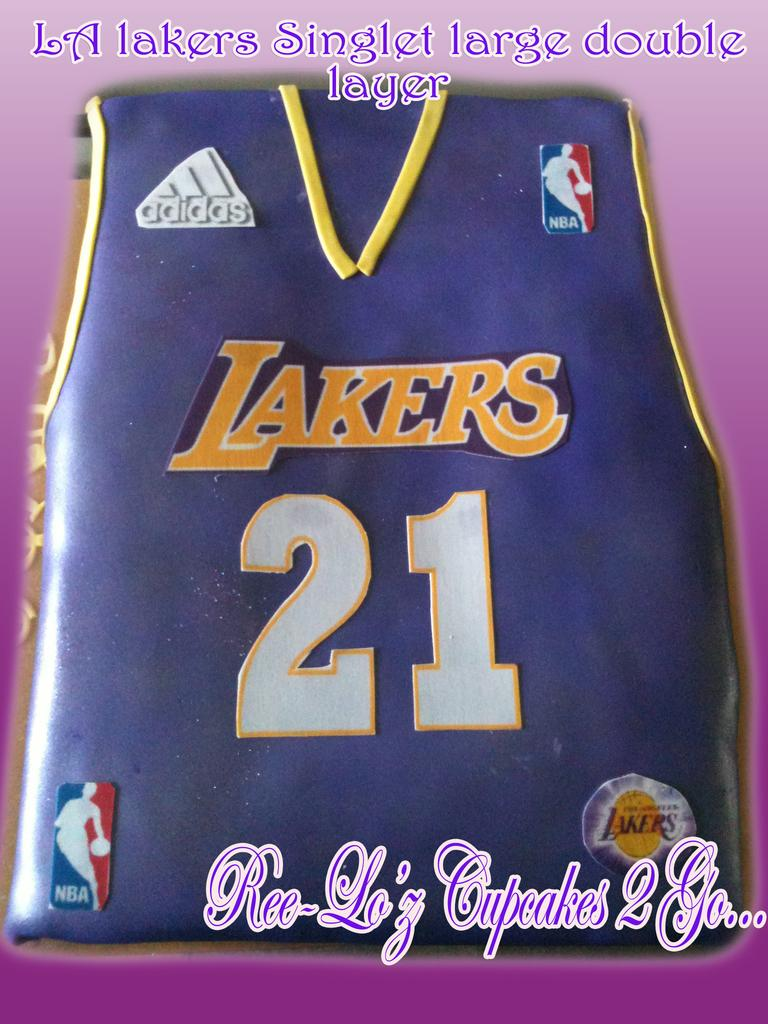<image>
Share a concise interpretation of the image provided. Cake version of a jersey which shows the number 21. 